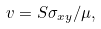Convert formula to latex. <formula><loc_0><loc_0><loc_500><loc_500>v = S \sigma _ { x y } / \mu ,</formula> 